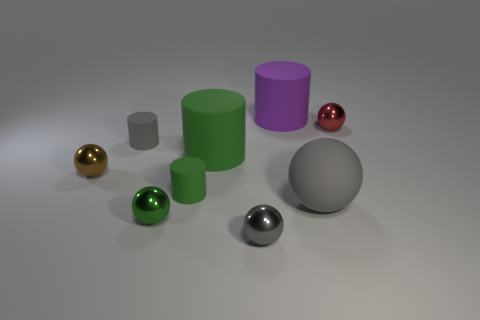Subtract all red balls. How many balls are left? 4 Subtract all small gray spheres. How many spheres are left? 4 Subtract all yellow balls. Subtract all green cubes. How many balls are left? 5 Subtract all cylinders. How many objects are left? 5 Add 2 small brown things. How many small brown things are left? 3 Add 7 red metal objects. How many red metal objects exist? 8 Subtract 0 yellow balls. How many objects are left? 9 Subtract all small gray metal things. Subtract all matte cylinders. How many objects are left? 4 